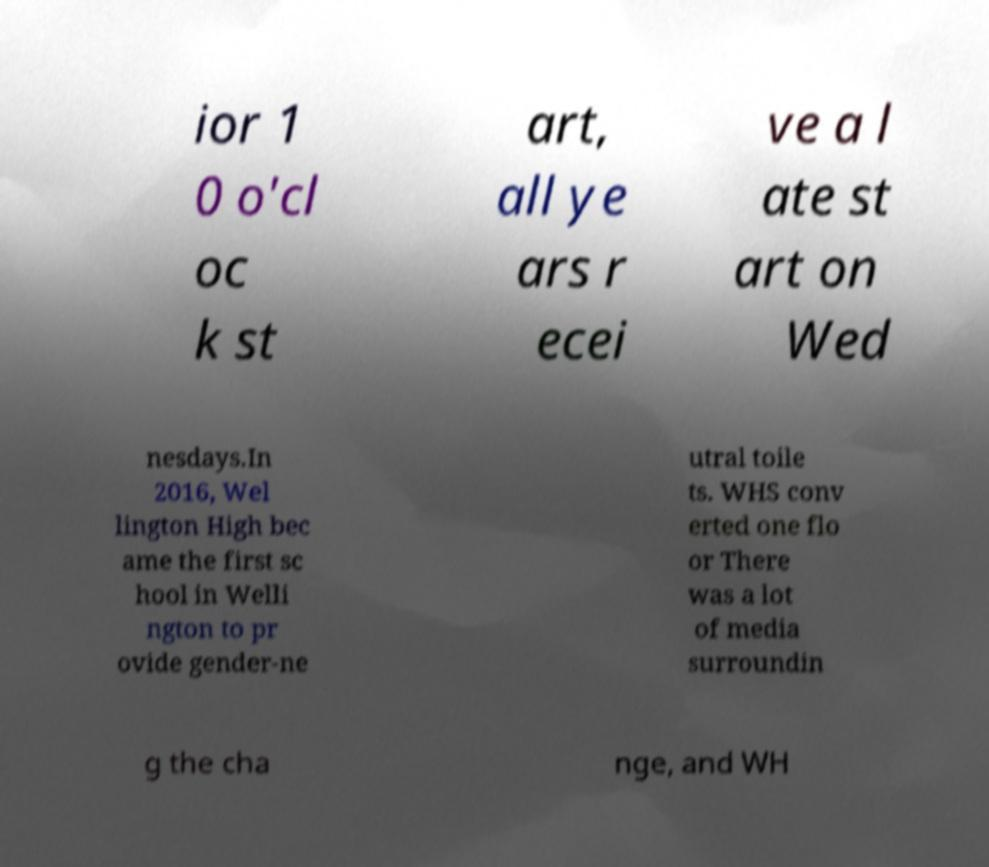For documentation purposes, I need the text within this image transcribed. Could you provide that? ior 1 0 o'cl oc k st art, all ye ars r ecei ve a l ate st art on Wed nesdays.In 2016, Wel lington High bec ame the first sc hool in Welli ngton to pr ovide gender-ne utral toile ts. WHS conv erted one flo or There was a lot of media surroundin g the cha nge, and WH 